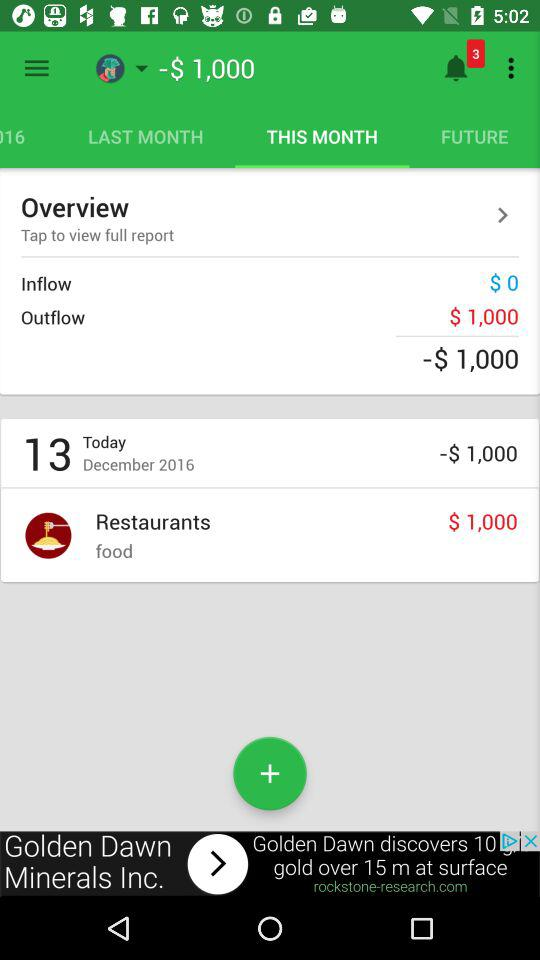How much more money is in outflow than inflow?
Answer the question using a single word or phrase. $1,000 